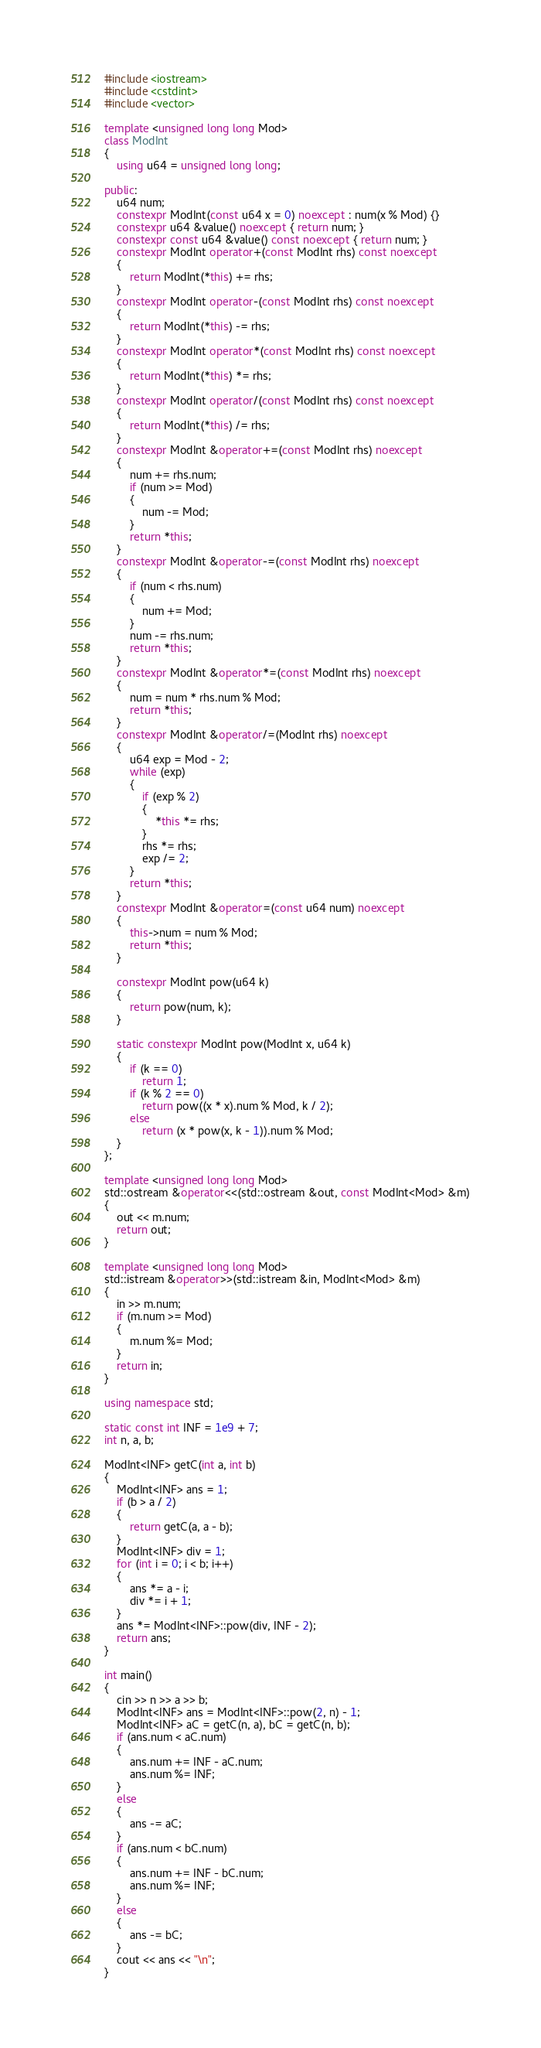<code> <loc_0><loc_0><loc_500><loc_500><_C++_>#include <iostream>
#include <cstdint>
#include <vector>

template <unsigned long long Mod>
class ModInt
{
    using u64 = unsigned long long;

public:
    u64 num;
    constexpr ModInt(const u64 x = 0) noexcept : num(x % Mod) {}
    constexpr u64 &value() noexcept { return num; }
    constexpr const u64 &value() const noexcept { return num; }
    constexpr ModInt operator+(const ModInt rhs) const noexcept
    {
        return ModInt(*this) += rhs;
    }
    constexpr ModInt operator-(const ModInt rhs) const noexcept
    {
        return ModInt(*this) -= rhs;
    }
    constexpr ModInt operator*(const ModInt rhs) const noexcept
    {
        return ModInt(*this) *= rhs;
    }
    constexpr ModInt operator/(const ModInt rhs) const noexcept
    {
        return ModInt(*this) /= rhs;
    }
    constexpr ModInt &operator+=(const ModInt rhs) noexcept
    {
        num += rhs.num;
        if (num >= Mod)
        {
            num -= Mod;
        }
        return *this;
    }
    constexpr ModInt &operator-=(const ModInt rhs) noexcept
    {
        if (num < rhs.num)
        {
            num += Mod;
        }
        num -= rhs.num;
        return *this;
    }
    constexpr ModInt &operator*=(const ModInt rhs) noexcept
    {
        num = num * rhs.num % Mod;
        return *this;
    }
    constexpr ModInt &operator/=(ModInt rhs) noexcept
    {
        u64 exp = Mod - 2;
        while (exp)
        {
            if (exp % 2)
            {
                *this *= rhs;
            }
            rhs *= rhs;
            exp /= 2;
        }
        return *this;
    }
    constexpr ModInt &operator=(const u64 num) noexcept
    {
        this->num = num % Mod;
        return *this;
    }

    constexpr ModInt pow(u64 k)
    {
        return pow(num, k);
    }

    static constexpr ModInt pow(ModInt x, u64 k)
    {
        if (k == 0)
            return 1;
        if (k % 2 == 0)
            return pow((x * x).num % Mod, k / 2);
        else
            return (x * pow(x, k - 1)).num % Mod;
    }
};

template <unsigned long long Mod>
std::ostream &operator<<(std::ostream &out, const ModInt<Mod> &m)
{
    out << m.num;
    return out;
}

template <unsigned long long Mod>
std::istream &operator>>(std::istream &in, ModInt<Mod> &m)
{
    in >> m.num;
    if (m.num >= Mod)
    {
        m.num %= Mod;
    }
    return in;
}

using namespace std;

static const int INF = 1e9 + 7;
int n, a, b;

ModInt<INF> getC(int a, int b)
{
    ModInt<INF> ans = 1;
    if (b > a / 2)
    {
        return getC(a, a - b);
    }
    ModInt<INF> div = 1;
    for (int i = 0; i < b; i++)
    {
        ans *= a - i;
        div *= i + 1;
    }
    ans *= ModInt<INF>::pow(div, INF - 2);
    return ans;
}

int main()
{
    cin >> n >> a >> b;
    ModInt<INF> ans = ModInt<INF>::pow(2, n) - 1;
    ModInt<INF> aC = getC(n, a), bC = getC(n, b);
    if (ans.num < aC.num)
    {
        ans.num += INF - aC.num;
        ans.num %= INF;
    }
    else
    {
        ans -= aC;
    }
    if (ans.num < bC.num)
    {
        ans.num += INF - bC.num;
        ans.num %= INF;
    }
    else
    {
        ans -= bC;
    }
    cout << ans << "\n";
}</code> 